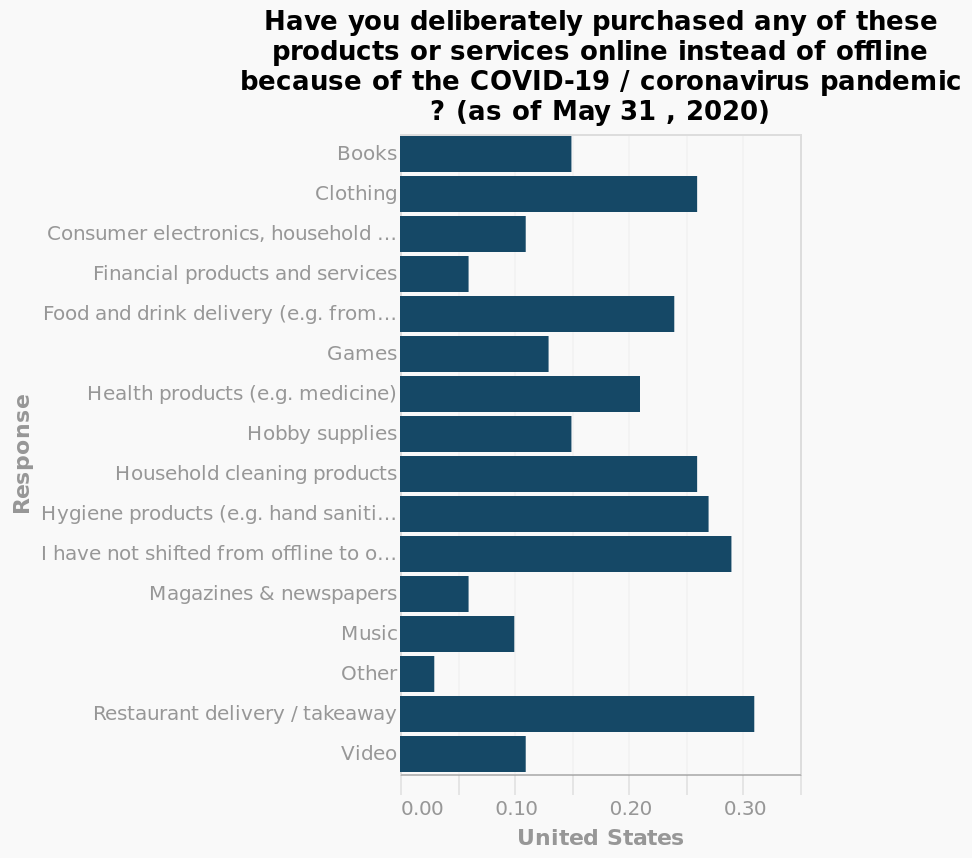<image>
What is the main change in the mode of shopping?  The main change in the mode of shopping is a massive shift from offline to online. Is the bar diagram depicting the percentage of people in the United States who chose to purchase products or services online instead of offline during the COVID-19 pandemic? No, the bar diagram does not represent the percentage. It simply illustrates the response of individuals in the United States. please enumerates aspects of the construction of the chart Have you deliberately purchased any of these products or services online instead of offline because of the COVID-19 / coronavirus pandemic ? (as of May 31 , 2020) is a bar diagram. Along the x-axis, United States is drawn. Along the y-axis, Response is defined. Is the main change in the mode of shopping a small shift from offline to online? No. The main change in the mode of shopping is a massive shift from offline to online. 